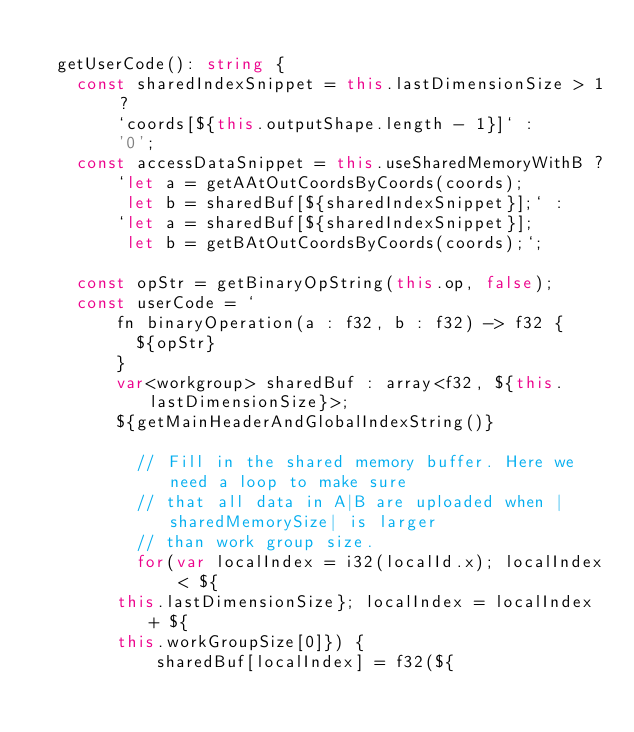<code> <loc_0><loc_0><loc_500><loc_500><_TypeScript_>
  getUserCode(): string {
    const sharedIndexSnippet = this.lastDimensionSize > 1 ?
        `coords[${this.outputShape.length - 1}]` :
        '0';
    const accessDataSnippet = this.useSharedMemoryWithB ?
        `let a = getAAtOutCoordsByCoords(coords);
         let b = sharedBuf[${sharedIndexSnippet}];` :
        `let a = sharedBuf[${sharedIndexSnippet}];
         let b = getBAtOutCoordsByCoords(coords);`;

    const opStr = getBinaryOpString(this.op, false);
    const userCode = `
        fn binaryOperation(a : f32, b : f32) -> f32 {
          ${opStr}
        }
        var<workgroup> sharedBuf : array<f32, ${this.lastDimensionSize}>;
        ${getMainHeaderAndGlobalIndexString()}

          // Fill in the shared memory buffer. Here we need a loop to make sure
          // that all data in A|B are uploaded when |sharedMemorySize| is larger
          // than work group size.
          for(var localIndex = i32(localId.x); localIndex < ${
        this.lastDimensionSize}; localIndex = localIndex + ${
        this.workGroupSize[0]}) {
            sharedBuf[localIndex] = f32(${</code> 